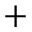<formula> <loc_0><loc_0><loc_500><loc_500>+</formula> 